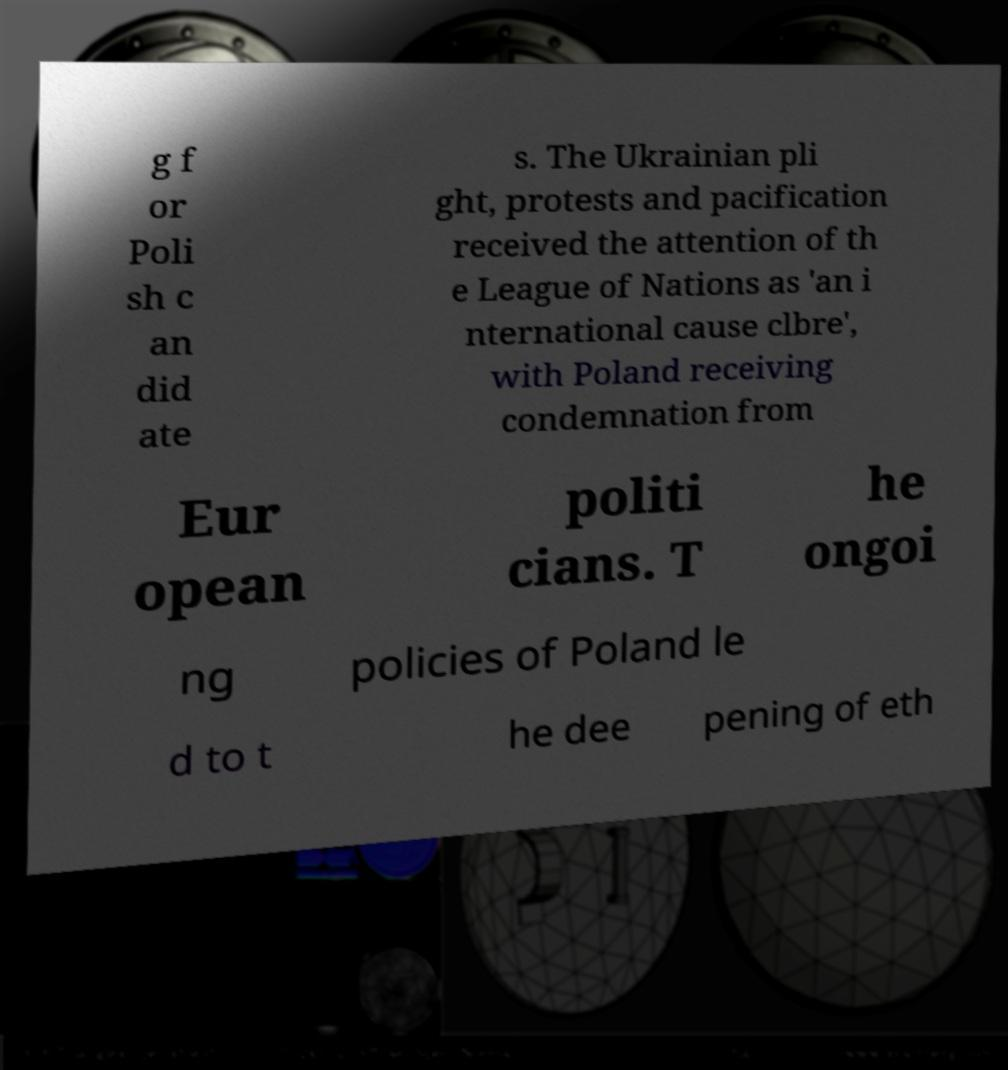Please read and relay the text visible in this image. What does it say? g f or Poli sh c an did ate s. The Ukrainian pli ght, protests and pacification received the attention of th e League of Nations as 'an i nternational cause clbre', with Poland receiving condemnation from Eur opean politi cians. T he ongoi ng policies of Poland le d to t he dee pening of eth 